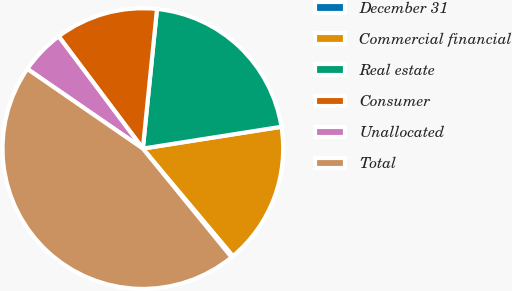Convert chart to OTSL. <chart><loc_0><loc_0><loc_500><loc_500><pie_chart><fcel>December 31<fcel>Commercial financial<fcel>Real estate<fcel>Consumer<fcel>Unallocated<fcel>Total<nl><fcel>0.21%<fcel>16.38%<fcel>20.91%<fcel>11.85%<fcel>5.15%<fcel>45.5%<nl></chart> 